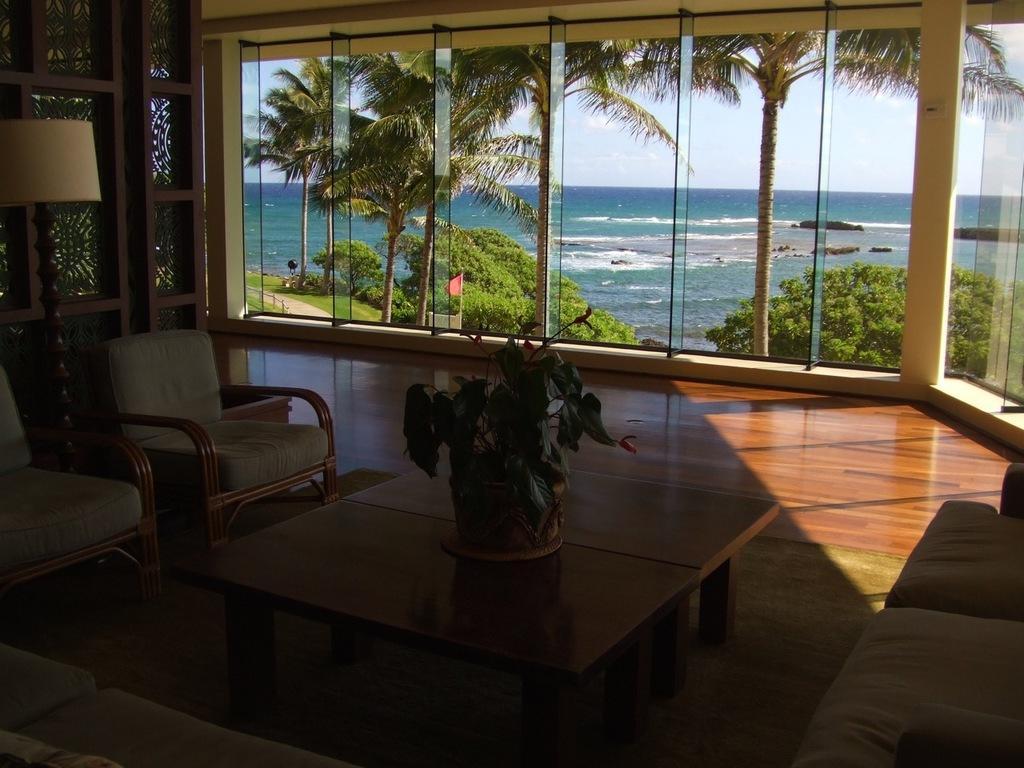How would you summarize this image in a sentence or two? Here we can see that a chairs, and table and flower vase on it, and here is the lamp on the floor, and here is the glass and trees, and here is the water. 